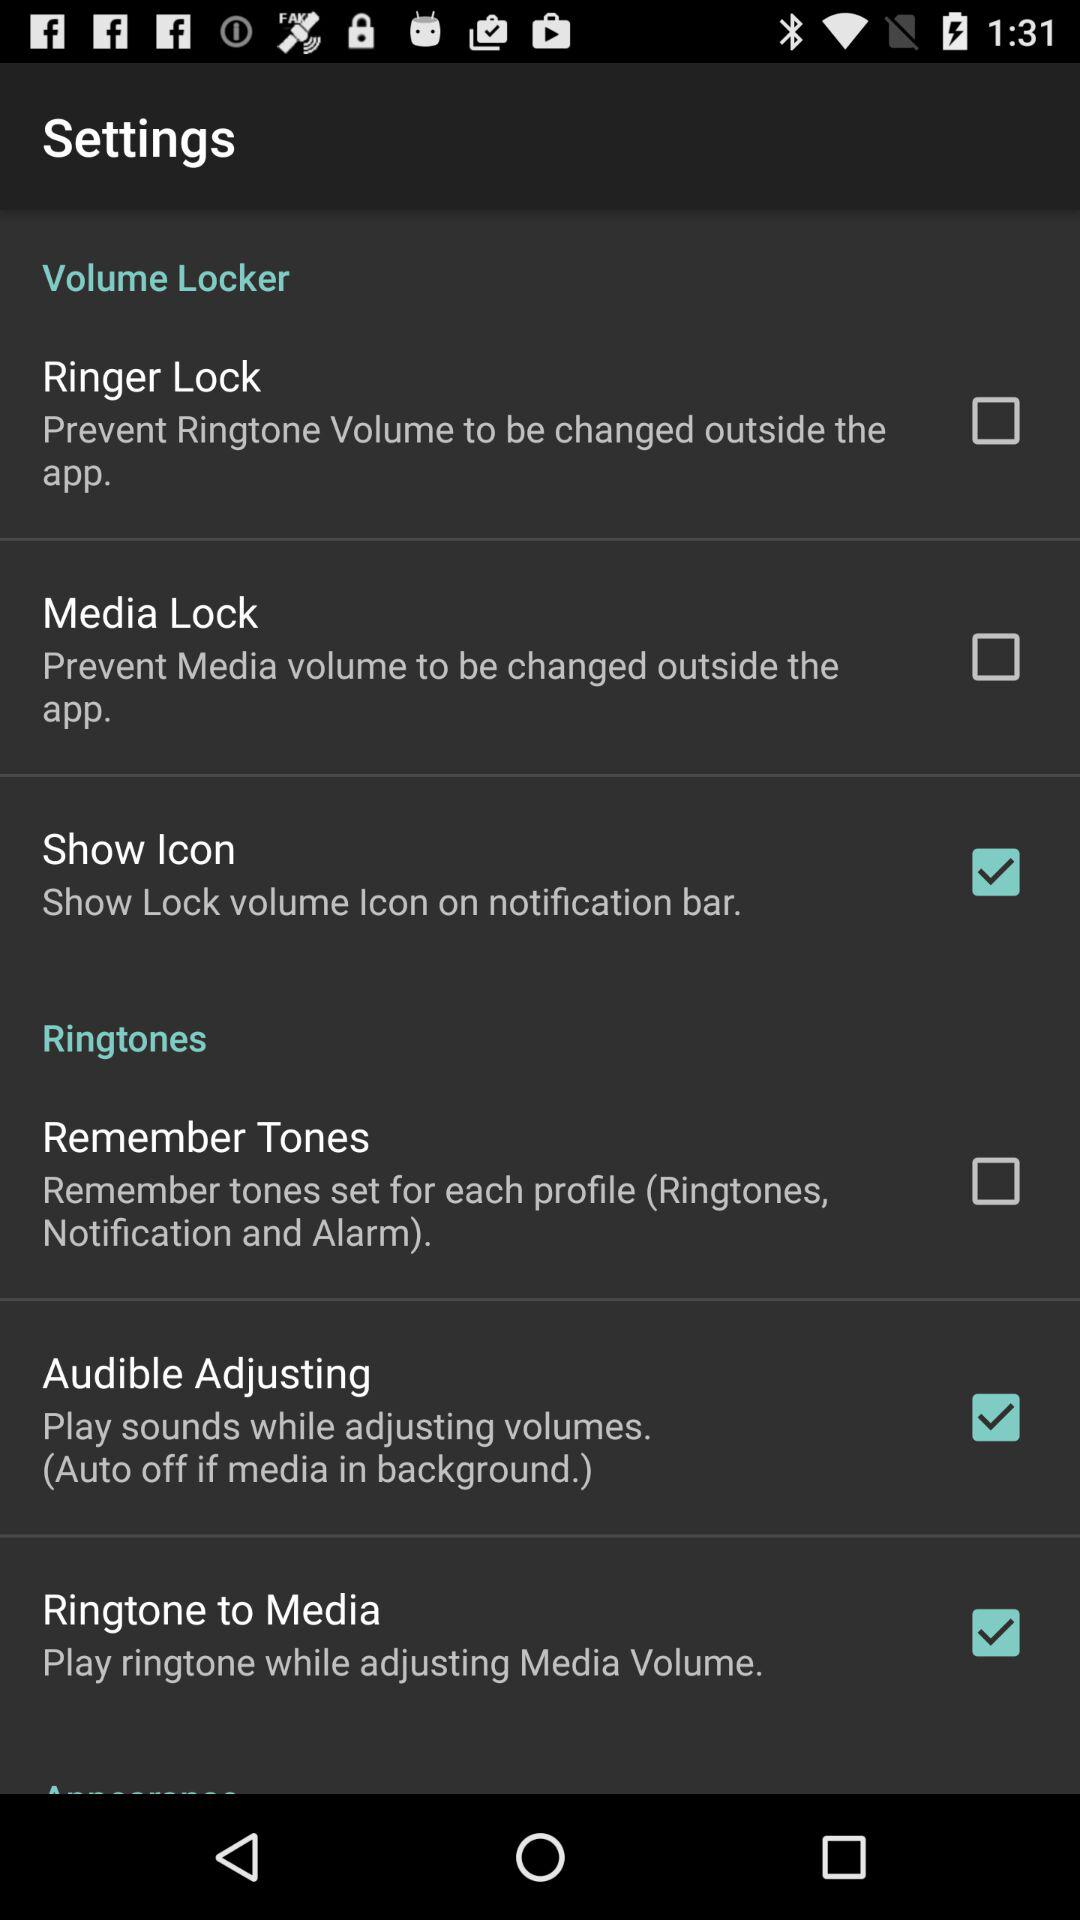What is the status of "Ringtone to Media"? The status is "on". 